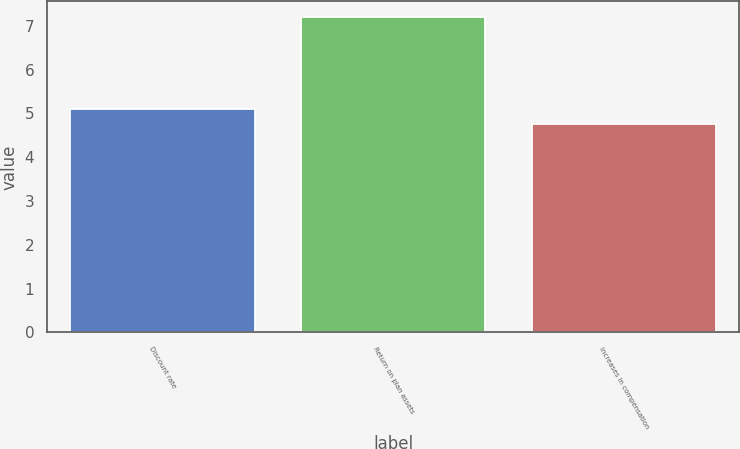Convert chart to OTSL. <chart><loc_0><loc_0><loc_500><loc_500><bar_chart><fcel>Discount rate<fcel>Return on plan assets<fcel>Increases in compensation<nl><fcel>5.1<fcel>7.2<fcel>4.75<nl></chart> 